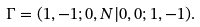Convert formula to latex. <formula><loc_0><loc_0><loc_500><loc_500>\Gamma = ( 1 , - 1 ; 0 , N | 0 , 0 ; 1 , - 1 ) .</formula> 